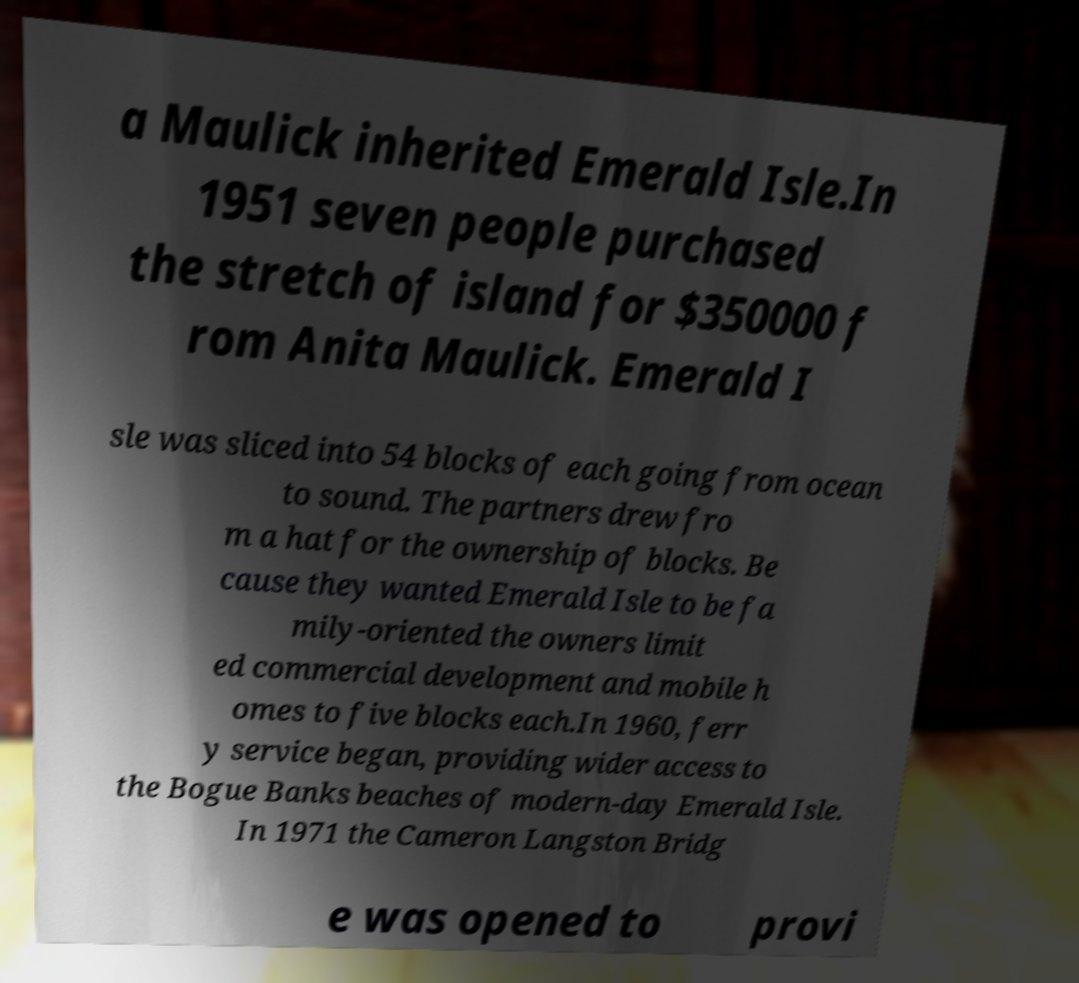Please identify and transcribe the text found in this image. a Maulick inherited Emerald Isle.In 1951 seven people purchased the stretch of island for $350000 f rom Anita Maulick. Emerald I sle was sliced into 54 blocks of each going from ocean to sound. The partners drew fro m a hat for the ownership of blocks. Be cause they wanted Emerald Isle to be fa mily-oriented the owners limit ed commercial development and mobile h omes to five blocks each.In 1960, ferr y service began, providing wider access to the Bogue Banks beaches of modern-day Emerald Isle. In 1971 the Cameron Langston Bridg e was opened to provi 